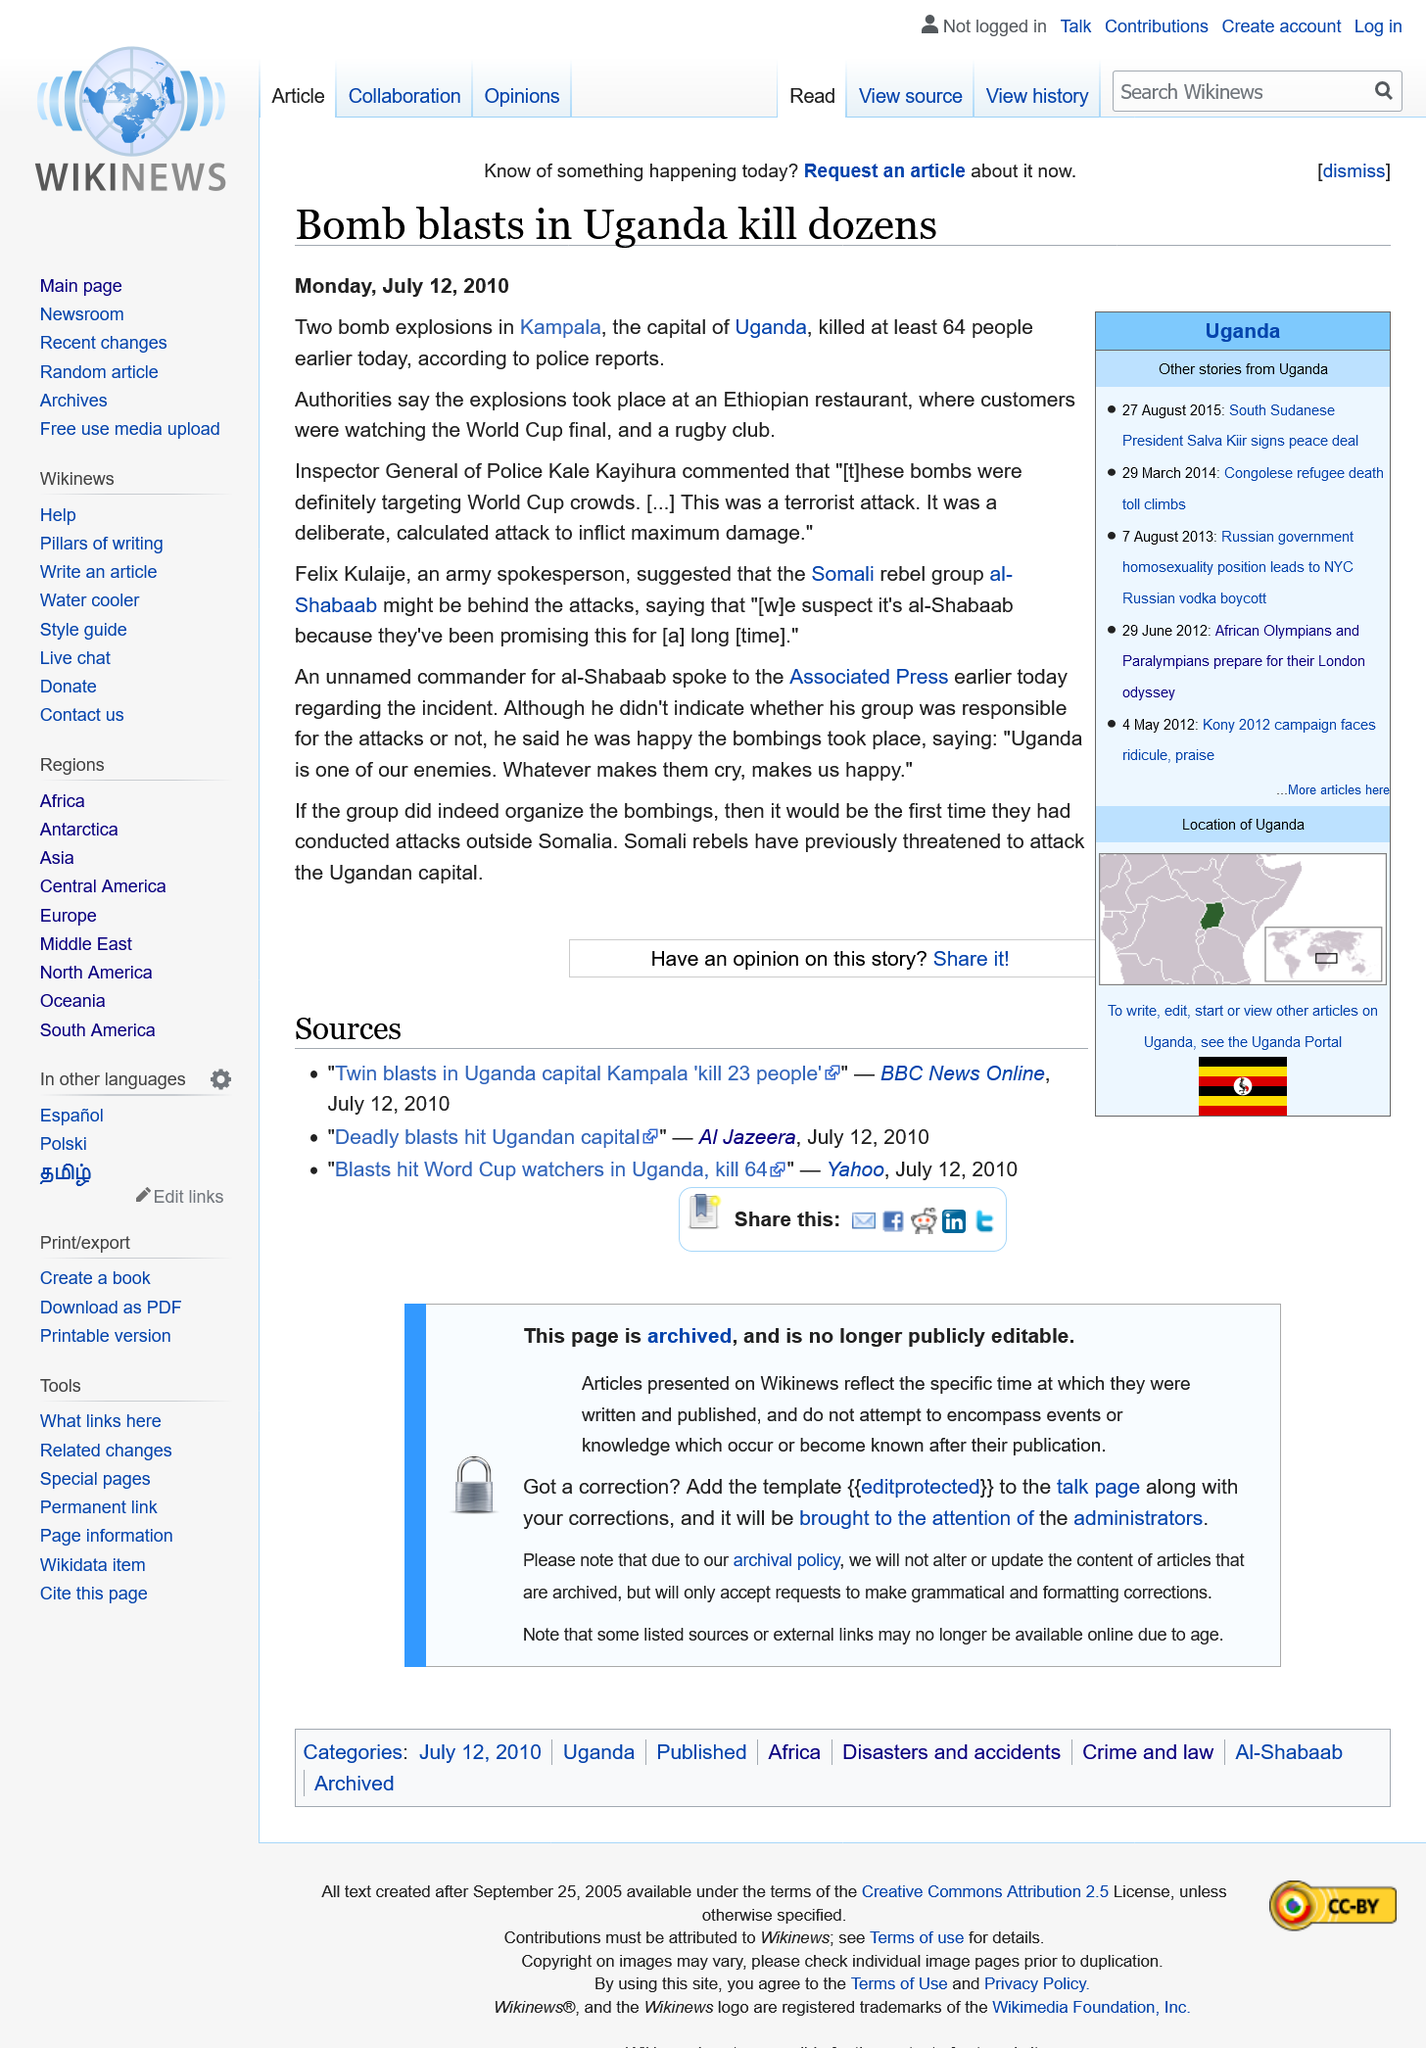Specify some key components in this picture. The bomb blasts took place in Uganda. The bombings took place at an Ethiopian restaurant. A total of two bomb blasts occurred. 